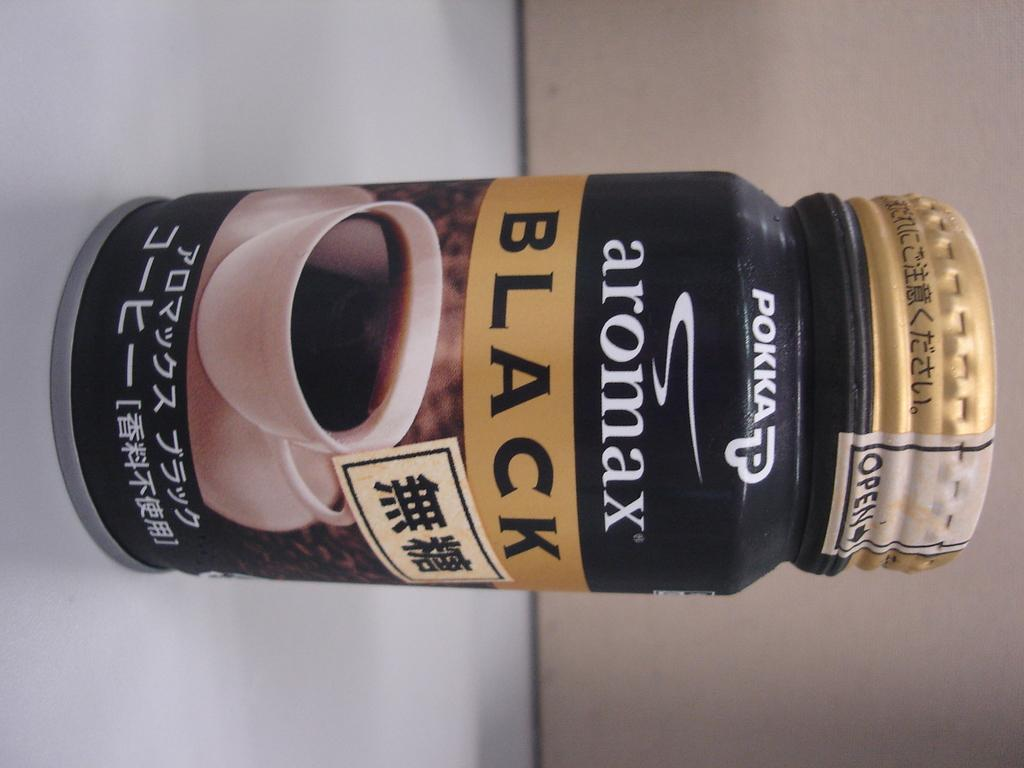<image>
Offer a succinct explanation of the picture presented. A black  bottle of aromax black coffee with a gold top 